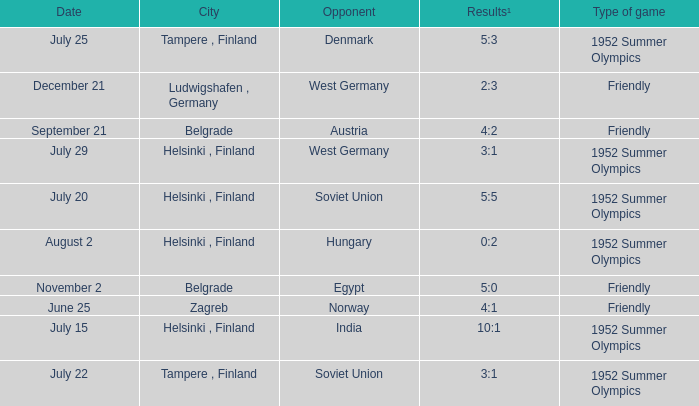What Type of game was played on Date of July 29? 1952 Summer Olympics. 